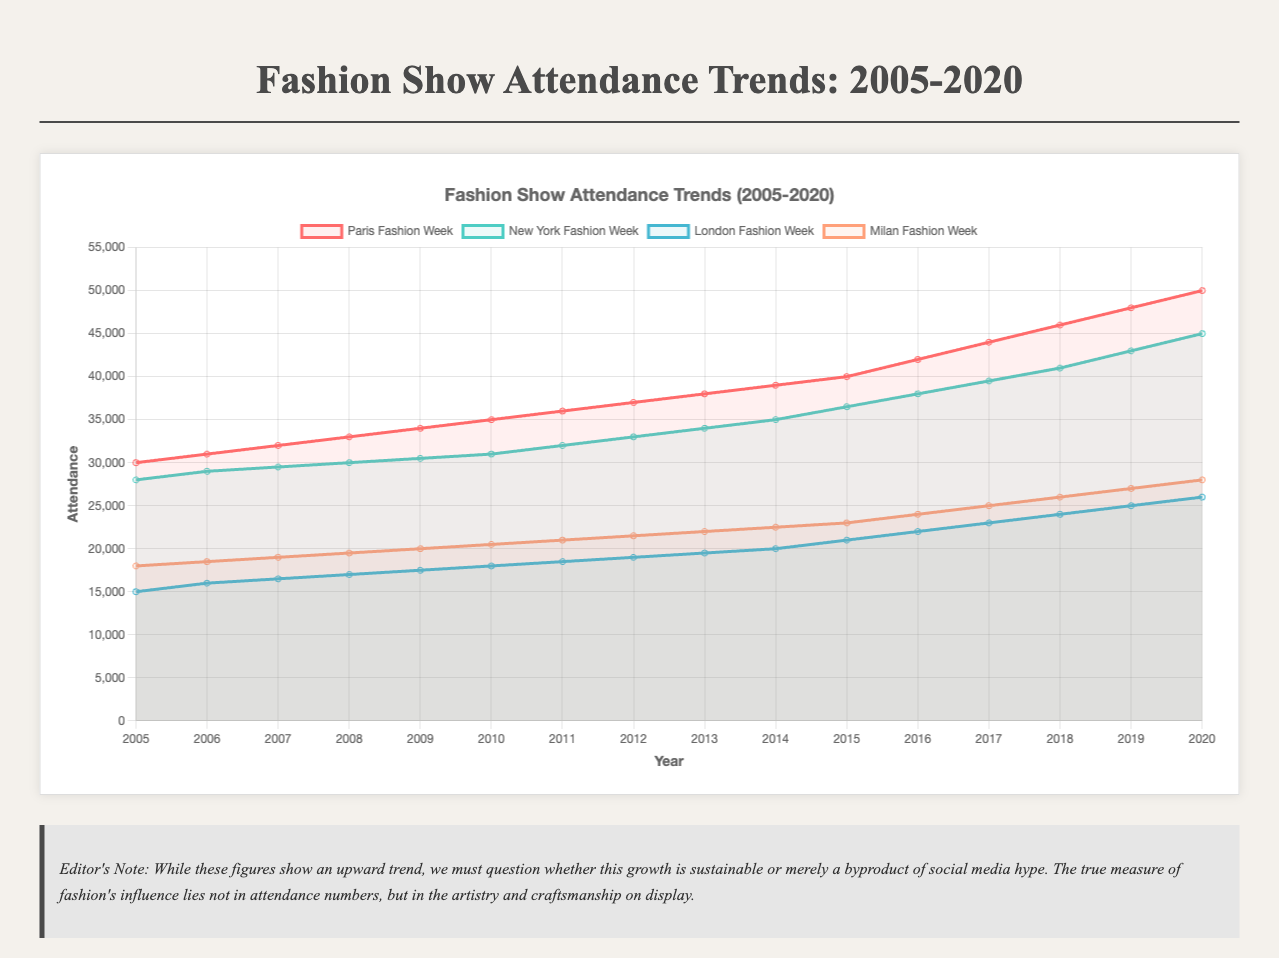What is the overall trend in attendance for Paris Fashion Week from 2005 to 2020? The trend for Paris Fashion Week shows a consistent increase in attendance. Starting at 30,000 in 2005 and ending at 50,000 in 2020.
Answer: Consistent increase Which year had the highest attendance for New York Fashion Week, and what was the attendance number? By examining the New York Fashion Week line, the highest attendance is seen in 2020 with 45,000 attendees.
Answer: 2020, 45,000 Between which consecutive years did London Fashion Week see the highest increase in attendance? The jump is most significant from 2014 to 2015, with an increase from 20,000 to 21,000 attendees.
Answer: 2014-2015 Compare the trendlines of Milan Fashion Week and London Fashion Week. Which one has shown a higher rate of increase in attendance over the years? Milan Fashion Week's rise from 18,000 in 2005 to 28,000 in 2020 is a 10,000 increase. London Fashion Week increased from 15,000 to 26,000, an 11,000 increase. London Fashion Week shows a higher increment numerically, but Milan has a higher growth rate proportionally.
Answer: Milan Fashion Week (higher rate) What is the total attendance of all four fashion weeks in 2010? Sum of attendees in 2010: Paris (35,000) + New York (31,000) + London (18,000) + Milan (20,500) = 104,500.
Answer: 104,500 Which fashion week had the least variation in attendance throughout the years, judging by the visual trendlines? Observing the chart, London Fashion Week appears to have the least steep slope and shows the smallest variation in attendance.
Answer: London Fashion Week Calculate the average attendance of New York Fashion Week over the entire period? Total attendees: 28000 + 29000 + 29500 + 30000 + 30500 + 31000 + 32000 + 33000 + 34000 + 35000 + 36500 + 38000 + 39500 + 41000 + 43000 + 45000 = 501500. Average = 501500/16 = 31343.75.
Answer: 31343.75 Did Milan Fashion Week ever surpass New York Fashion Week in attendance in any given year? By comparing the intersecting lines, Milan Fashion Week never surpassed New York Fashion Week in attendance from 2005 to 2020.
Answer: No 